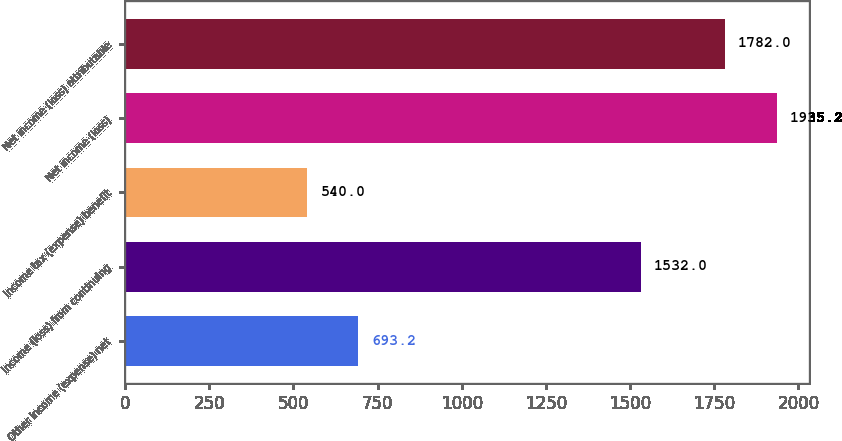Convert chart to OTSL. <chart><loc_0><loc_0><loc_500><loc_500><bar_chart><fcel>Other income (expense) net<fcel>Income (loss) from continuing<fcel>Income tax (expense) benefit<fcel>Net income (loss)<fcel>Net income (loss) attributable<nl><fcel>693.2<fcel>1532<fcel>540<fcel>1935.2<fcel>1782<nl></chart> 